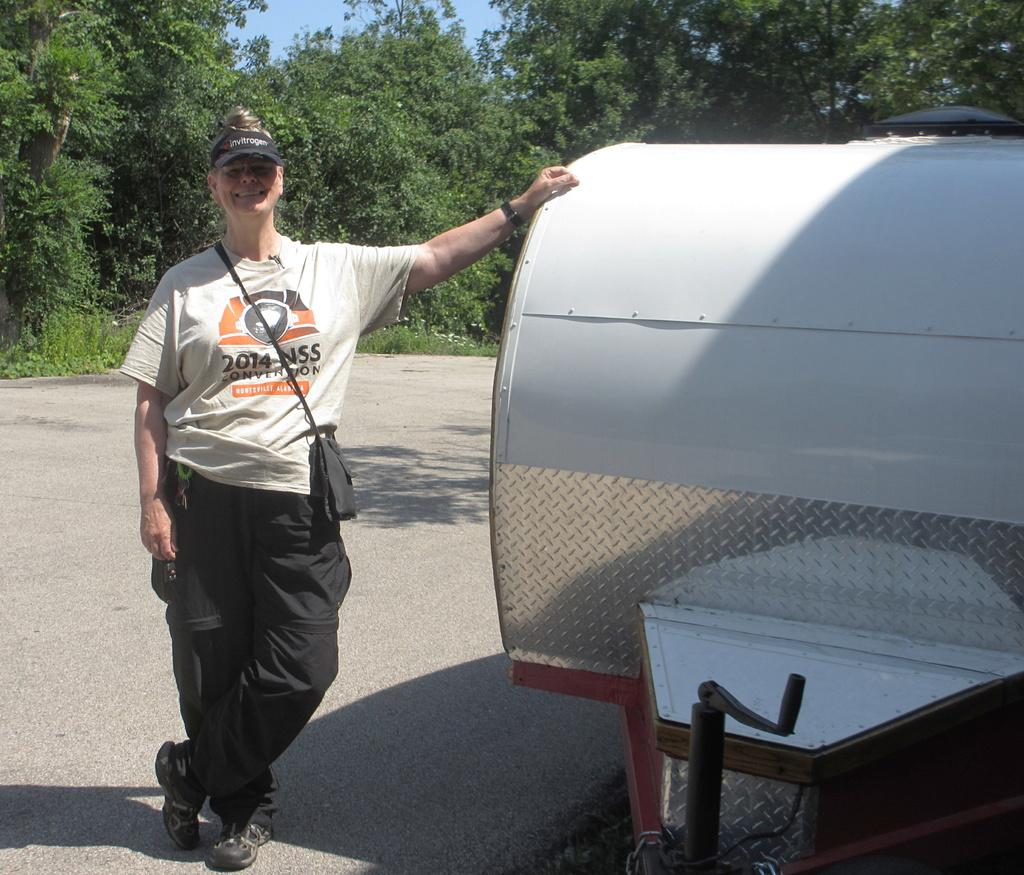What is located on the left side of the image? There is a woman on the left side of the image. What is the woman wearing? The woman is wearing a white t-shirt. What is the woman's facial expression? The woman is smiling. What is the woman doing with her hand? The woman is placing a hand on a vehicle. Where is the scene taking place? The scene is on a road. What can be seen in the background of the image? There are trees and the sky visible in the background of the image. What shape is the quartz on the woman's necklace in the image? There is no quartz or necklace visible in the image. 